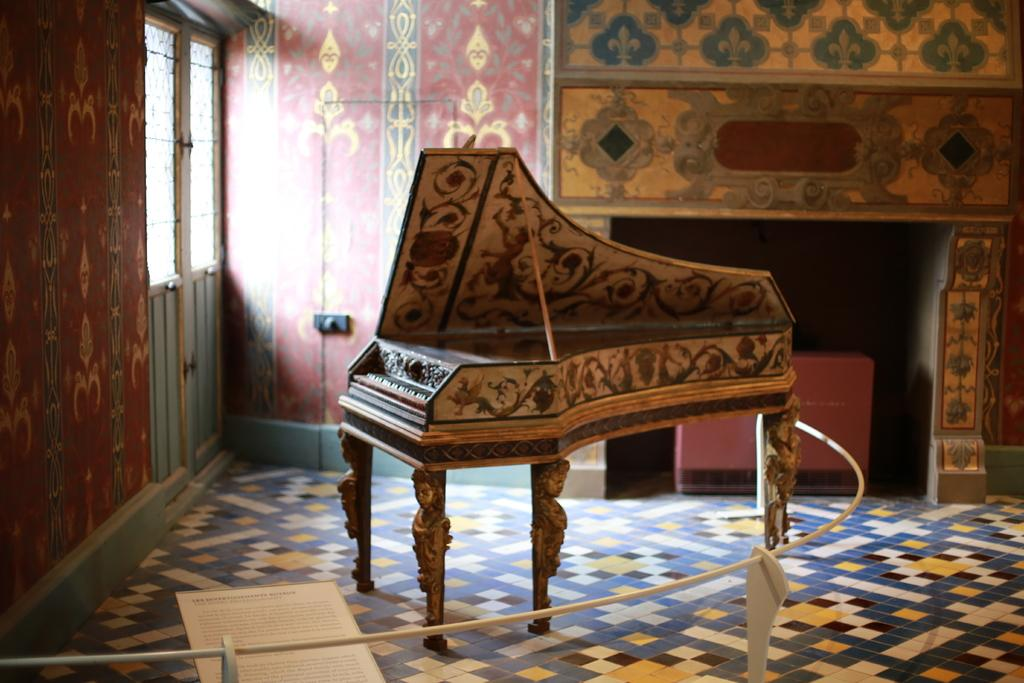What is placed on the floor in the image? There is a piano board on the floor. What is located behind the piano board? There is a door behind the piano board. What else can be seen behind the piano board? There is a wall behind the piano board. How many letters are visible on the piano board in the image? There are no letters visible on the piano board in the image. What type of coin can be seen on the piano board in the image? There is no coin, such as a dime, present on the piano board in the image. 